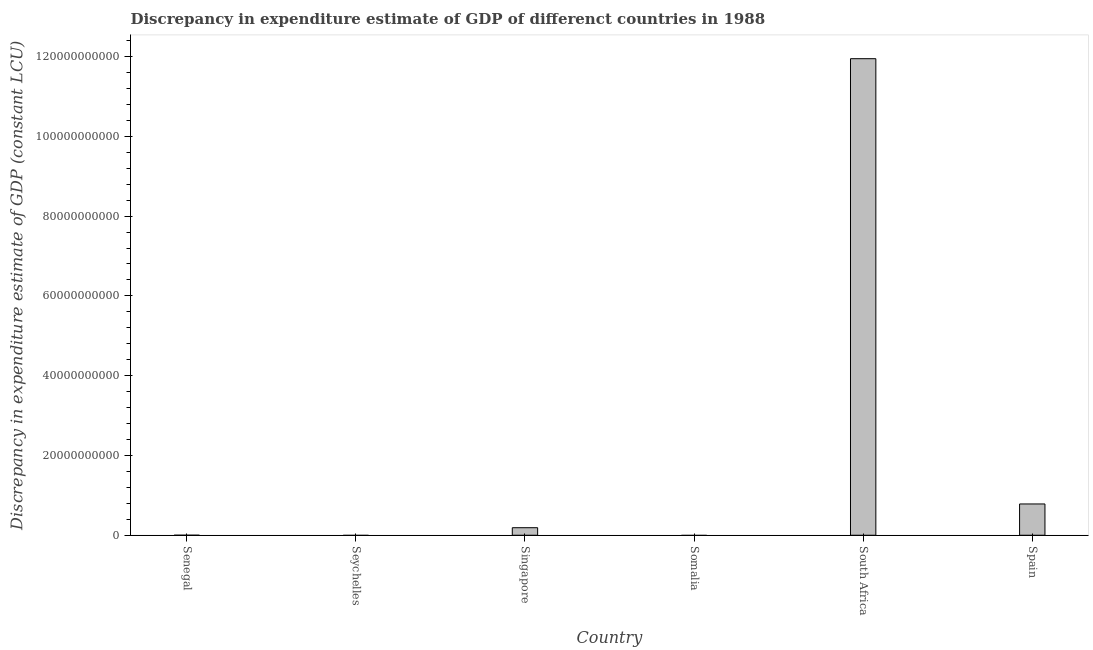Does the graph contain grids?
Offer a terse response. No. What is the title of the graph?
Your answer should be very brief. Discrepancy in expenditure estimate of GDP of differenct countries in 1988. What is the label or title of the X-axis?
Your answer should be very brief. Country. What is the label or title of the Y-axis?
Give a very brief answer. Discrepancy in expenditure estimate of GDP (constant LCU). What is the discrepancy in expenditure estimate of gdp in South Africa?
Make the answer very short. 1.19e+11. Across all countries, what is the maximum discrepancy in expenditure estimate of gdp?
Your answer should be very brief. 1.19e+11. In which country was the discrepancy in expenditure estimate of gdp maximum?
Provide a succinct answer. South Africa. What is the sum of the discrepancy in expenditure estimate of gdp?
Your answer should be compact. 1.29e+11. What is the difference between the discrepancy in expenditure estimate of gdp in South Africa and Spain?
Give a very brief answer. 1.12e+11. What is the average discrepancy in expenditure estimate of gdp per country?
Offer a very short reply. 2.15e+1. What is the median discrepancy in expenditure estimate of gdp?
Provide a succinct answer. 9.44e+08. What is the ratio of the discrepancy in expenditure estimate of gdp in Singapore to that in South Africa?
Offer a terse response. 0.02. Is the difference between the discrepancy in expenditure estimate of gdp in South Africa and Spain greater than the difference between any two countries?
Provide a succinct answer. No. What is the difference between the highest and the second highest discrepancy in expenditure estimate of gdp?
Provide a short and direct response. 1.12e+11. What is the difference between the highest and the lowest discrepancy in expenditure estimate of gdp?
Your answer should be very brief. 1.19e+11. How many countries are there in the graph?
Make the answer very short. 6. What is the difference between two consecutive major ticks on the Y-axis?
Give a very brief answer. 2.00e+1. Are the values on the major ticks of Y-axis written in scientific E-notation?
Keep it short and to the point. No. What is the Discrepancy in expenditure estimate of GDP (constant LCU) in Senegal?
Give a very brief answer. 0. What is the Discrepancy in expenditure estimate of GDP (constant LCU) of Seychelles?
Ensure brevity in your answer.  0. What is the Discrepancy in expenditure estimate of GDP (constant LCU) in Singapore?
Your answer should be compact. 1.89e+09. What is the Discrepancy in expenditure estimate of GDP (constant LCU) of Somalia?
Give a very brief answer. 0. What is the Discrepancy in expenditure estimate of GDP (constant LCU) of South Africa?
Give a very brief answer. 1.19e+11. What is the Discrepancy in expenditure estimate of GDP (constant LCU) of Spain?
Offer a terse response. 7.84e+09. What is the difference between the Discrepancy in expenditure estimate of GDP (constant LCU) in Singapore and South Africa?
Your answer should be very brief. -1.18e+11. What is the difference between the Discrepancy in expenditure estimate of GDP (constant LCU) in Singapore and Spain?
Your answer should be compact. -5.95e+09. What is the difference between the Discrepancy in expenditure estimate of GDP (constant LCU) in South Africa and Spain?
Ensure brevity in your answer.  1.12e+11. What is the ratio of the Discrepancy in expenditure estimate of GDP (constant LCU) in Singapore to that in South Africa?
Keep it short and to the point. 0.02. What is the ratio of the Discrepancy in expenditure estimate of GDP (constant LCU) in Singapore to that in Spain?
Offer a very short reply. 0.24. What is the ratio of the Discrepancy in expenditure estimate of GDP (constant LCU) in South Africa to that in Spain?
Provide a short and direct response. 15.24. 